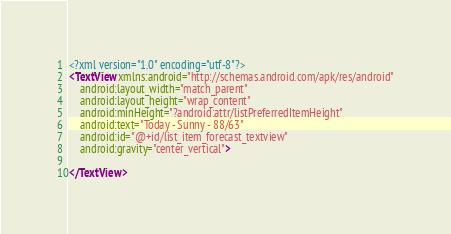Convert code to text. <code><loc_0><loc_0><loc_500><loc_500><_XML_><?xml version="1.0" encoding="utf-8"?>
<TextView xmlns:android="http://schemas.android.com/apk/res/android"
    android:layout_width="match_parent"
    android:layout_height="wrap_content"
    android:minHeight="?android:attr/listPreferredItemHeight"
    android:text="Today - Sunny - 88/63"
    android:id="@+id/list_item_forecast_textview"
    android:gravity="center_vertical">

</TextView></code> 